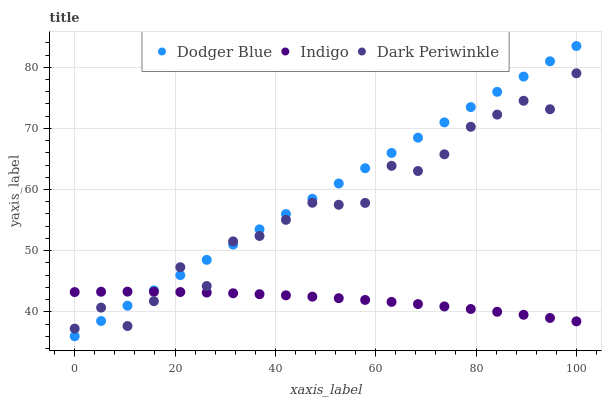Does Indigo have the minimum area under the curve?
Answer yes or no. Yes. Does Dodger Blue have the maximum area under the curve?
Answer yes or no. Yes. Does Dark Periwinkle have the minimum area under the curve?
Answer yes or no. No. Does Dark Periwinkle have the maximum area under the curve?
Answer yes or no. No. Is Dodger Blue the smoothest?
Answer yes or no. Yes. Is Dark Periwinkle the roughest?
Answer yes or no. Yes. Is Dark Periwinkle the smoothest?
Answer yes or no. No. Is Dodger Blue the roughest?
Answer yes or no. No. Does Dodger Blue have the lowest value?
Answer yes or no. Yes. Does Dark Periwinkle have the lowest value?
Answer yes or no. No. Does Dodger Blue have the highest value?
Answer yes or no. Yes. Does Dark Periwinkle have the highest value?
Answer yes or no. No. Does Indigo intersect Dodger Blue?
Answer yes or no. Yes. Is Indigo less than Dodger Blue?
Answer yes or no. No. Is Indigo greater than Dodger Blue?
Answer yes or no. No. 